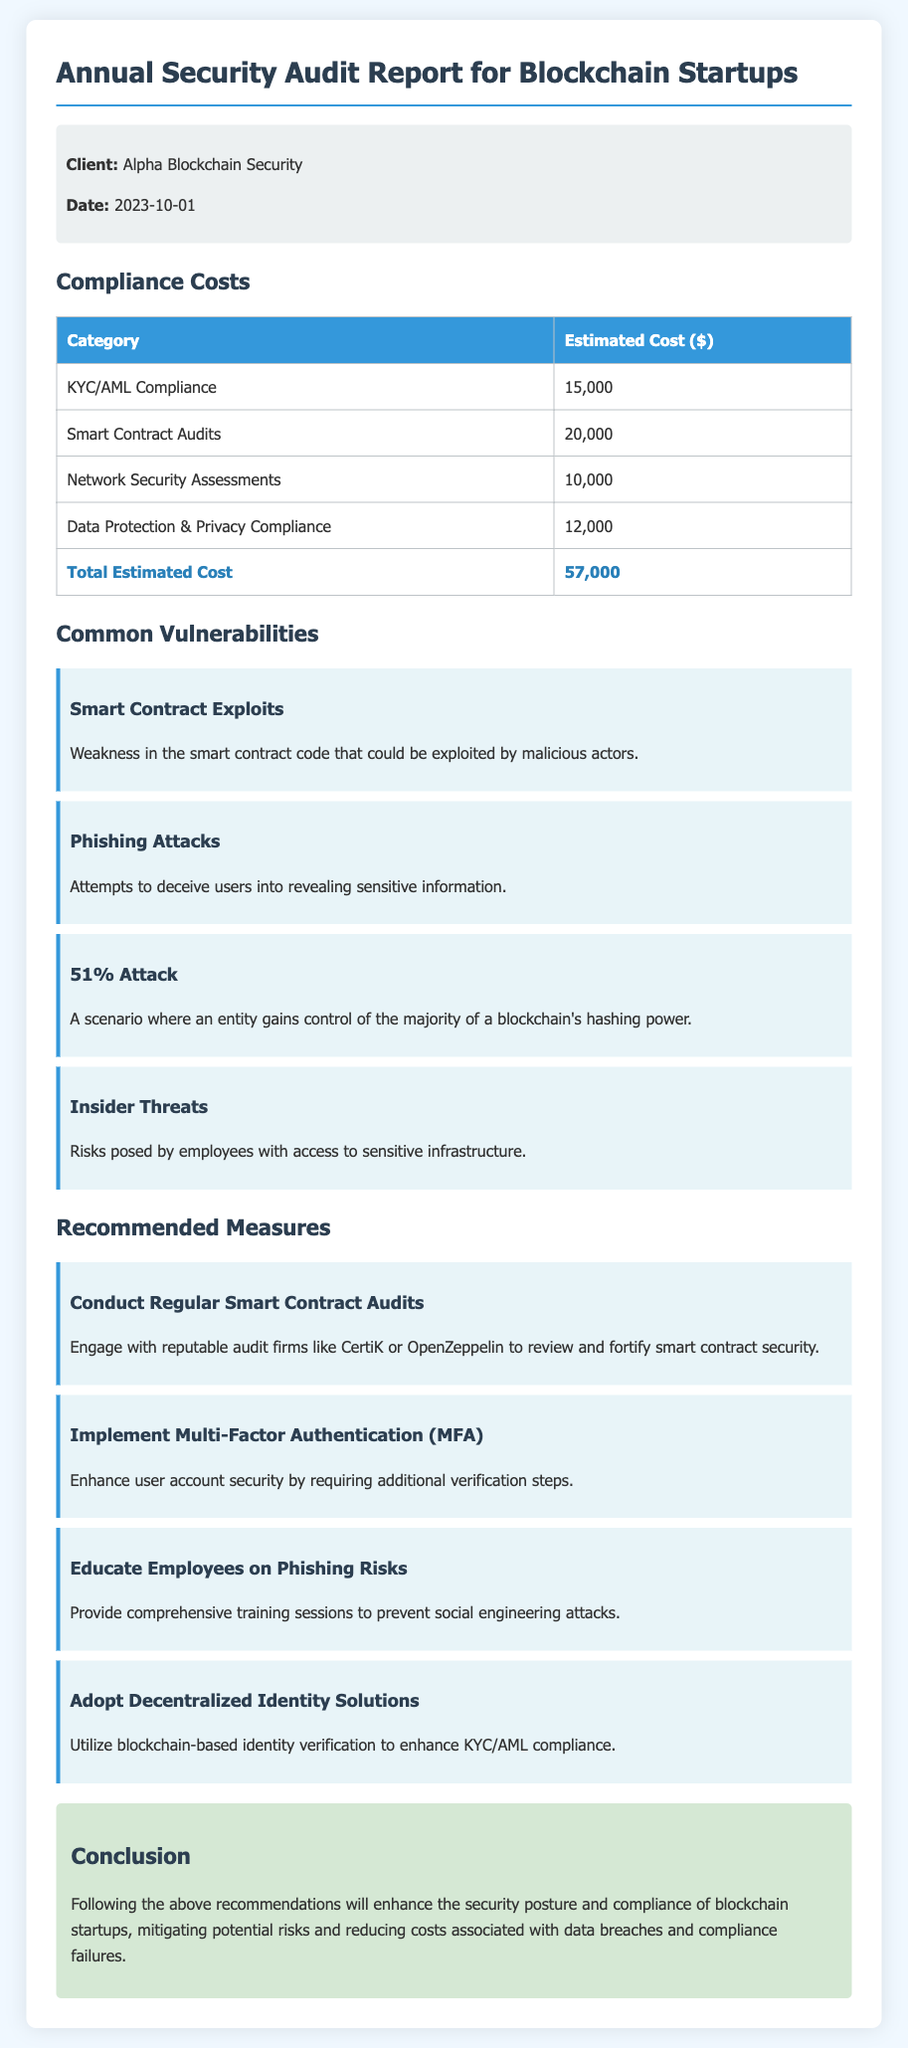What is the date of the report? The date of the report is provided in the document, which is 2023-10-01.
Answer: 2023-10-01 What is the total estimated compliance cost? The total estimated compliance cost is calculated as the sum of each category's costs, which is $57,000.
Answer: $57,000 Which category has the highest estimated cost? The category that has the highest estimated cost is Smart Contract Audits, with a cost of $20,000.
Answer: Smart Contract Audits What is one common vulnerability listed in the report? One common vulnerability listed in the report is Smart Contract Exploits, which relates to weak code.
Answer: Smart Contract Exploits What measure is recommended to enhance KYC/AML compliance? The document recommends adopting Decentralized Identity Solutions to enhance KYC/AML compliance.
Answer: Adopt Decentralized Identity Solutions What is a potential risk mentioned related to employees? A potential risk mentioned regarding employees is Insider Threats, where employees have access to sensitive information.
Answer: Insider Threats What is the general conclusion of the report? The general conclusion of the report emphasizes enhancing security and compliance to mitigate risks and reduce costs.
Answer: Enhance security and compliance Which company conducted the audit? The client mentioned in the report, who received the audit, is Alpha Blockchain Security.
Answer: Alpha Blockchain Security What is one recommended measure to combat phishing attacks? The report recommends educating employees on phishing risks as a measure to combat them.
Answer: Educate Employees on Phishing Risks 